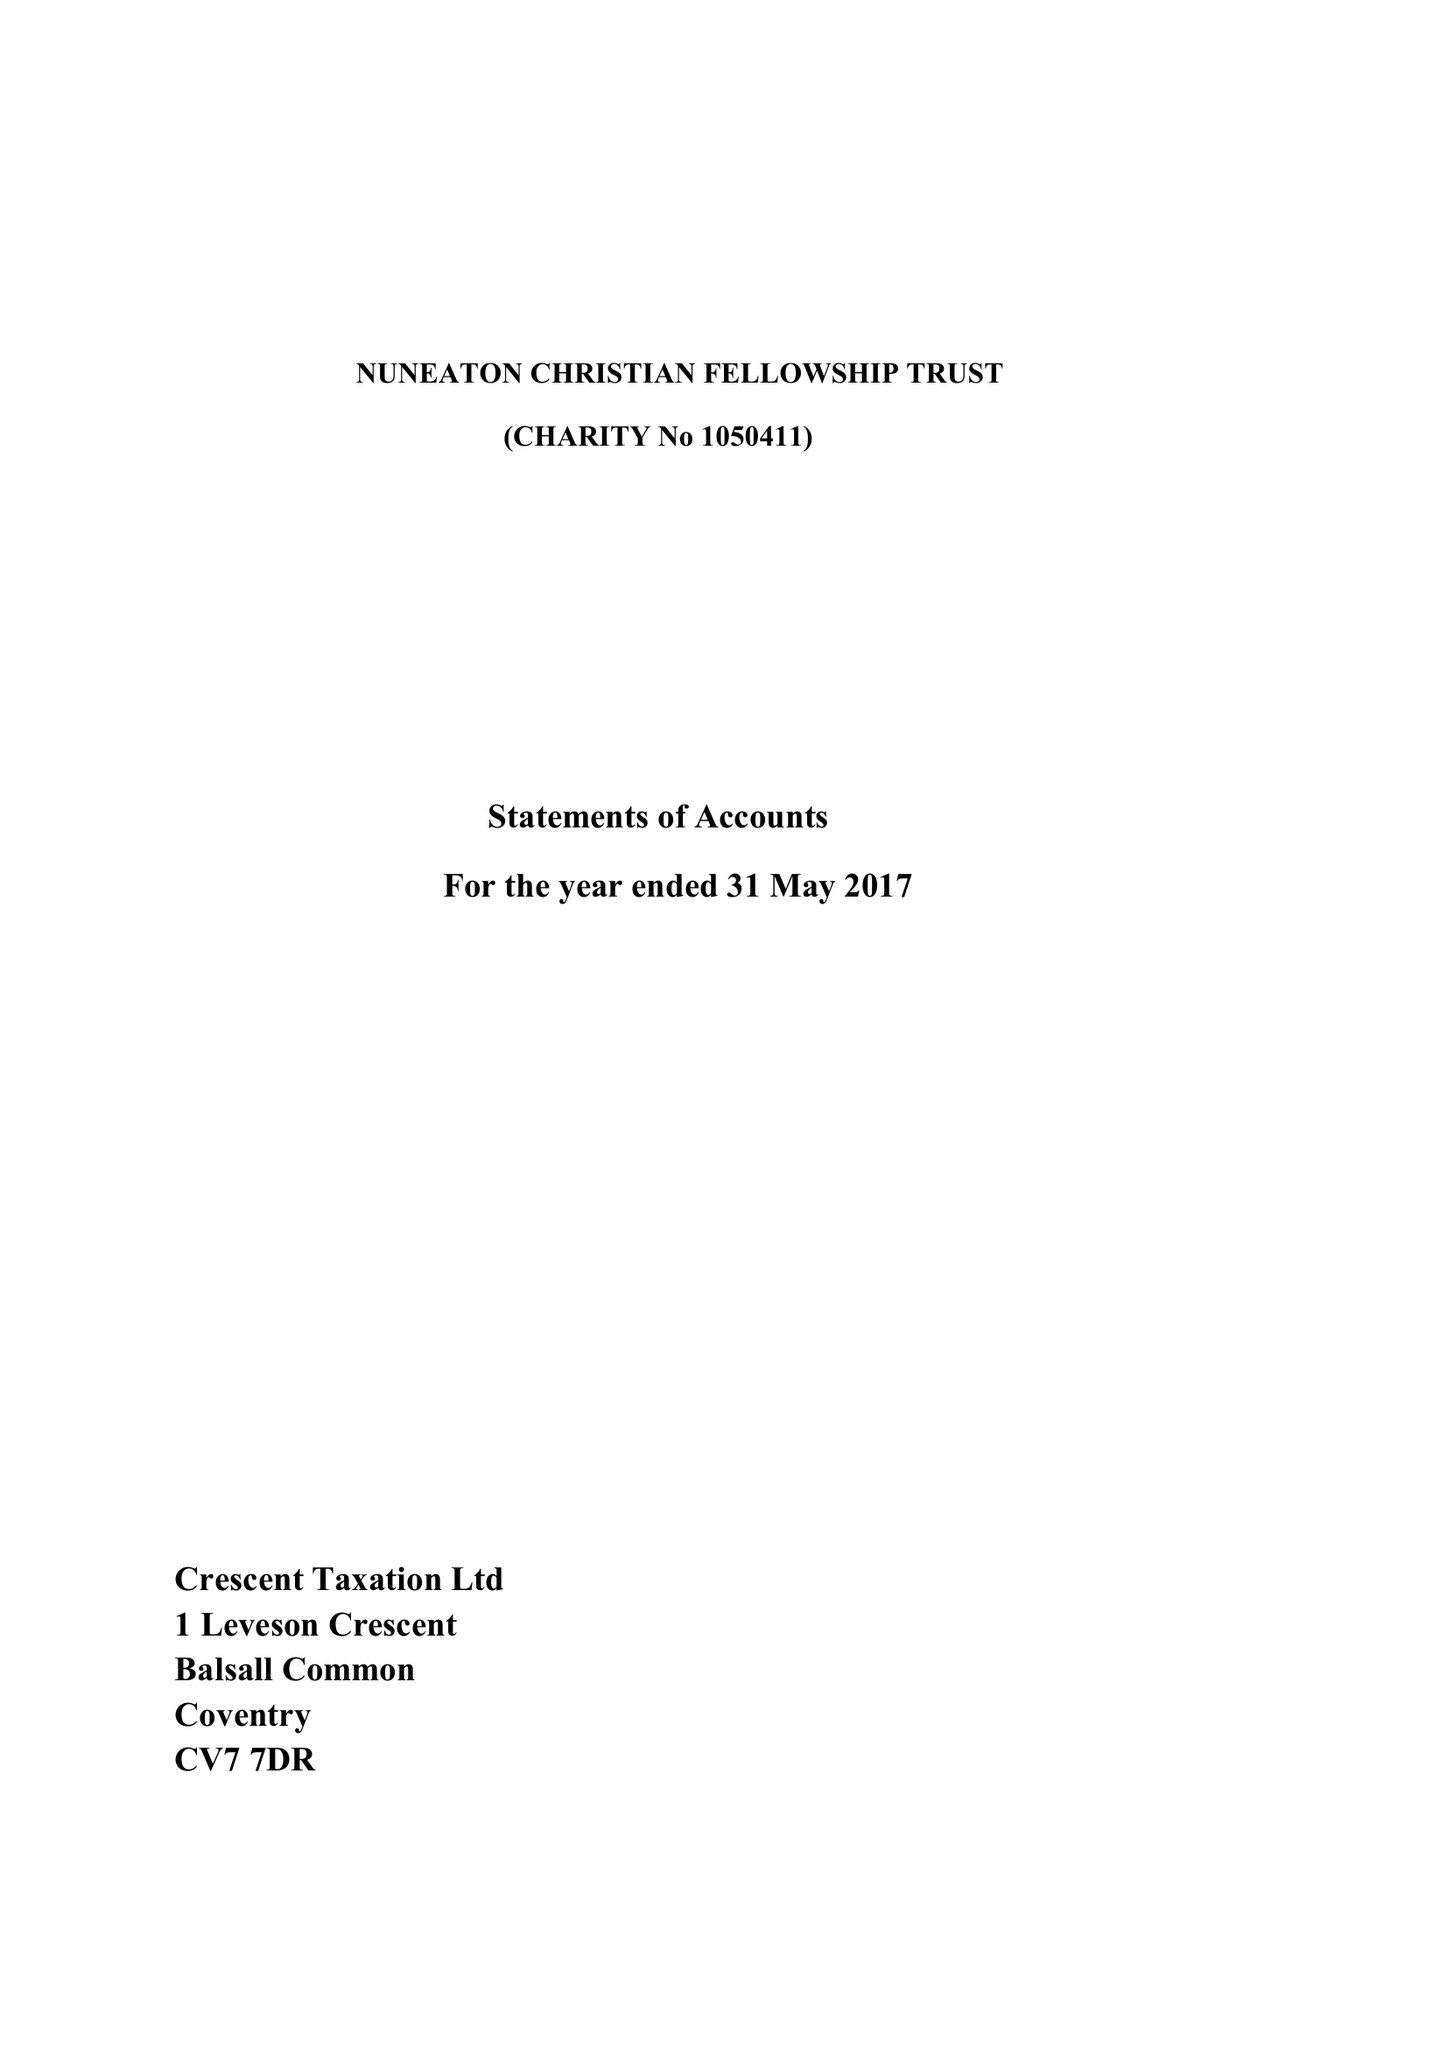What is the value for the spending_annually_in_british_pounds?
Answer the question using a single word or phrase. 34965.00 